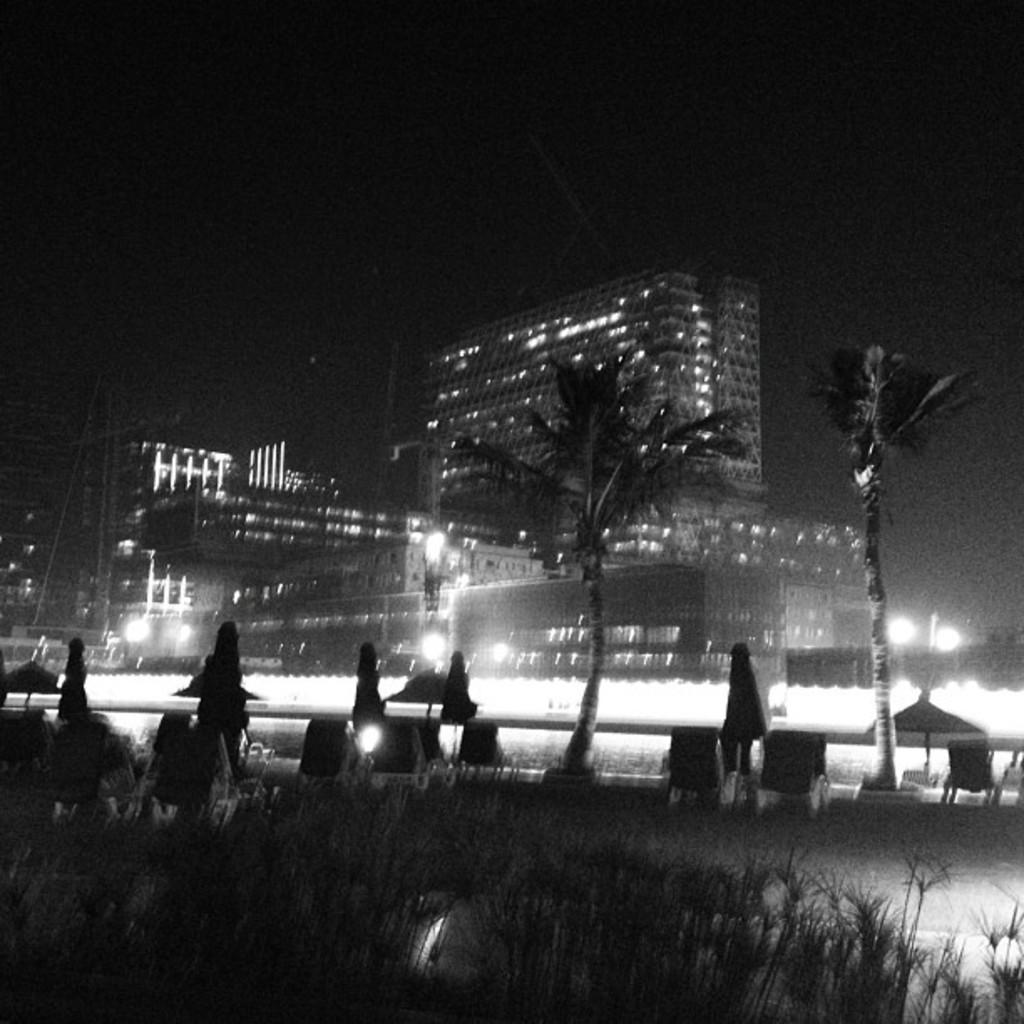What type of structures are present in the image? There are buildings in the image. What feature do the buildings have? The buildings have lights. What type of vegetation is visible in the image? There are plants and trees in the image. What time of day is the maid taking a break in the image? There is no maid present in the image, so it is not possible to determine the time of day or any activities related to a maid. 